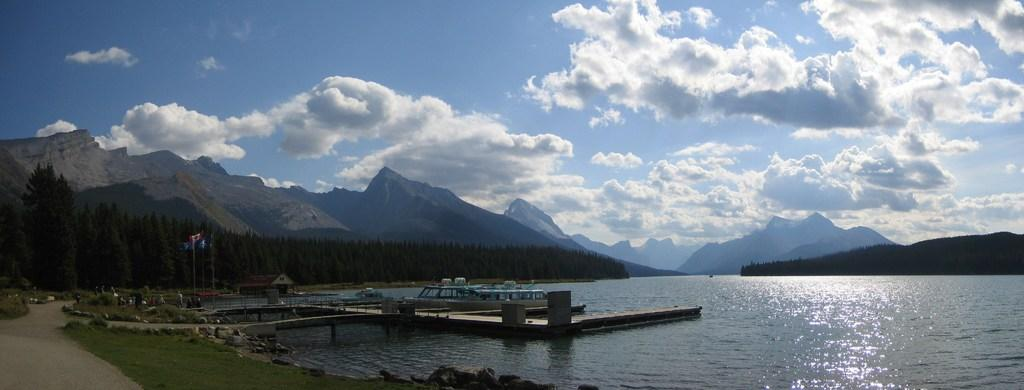What can be seen in the water in the image? There are many boats in the water. What is located to the left of the image? There is grass to the left of the image. What objects are present in the image that are not related to the boats or water? There are poles and flags in the image. What can be seen in the background of the image? There are trees, mountains, clouds, and the sky visible in the background of the image. What type of impulse can be seen affecting the boats in the image? There is no indication of any impulse affecting the boats in the image; they are stationary in the water. What kind of advice can be given to the trees in the background of the image? There is no need to give advice to the trees in the image, as they are not sentient beings capable of understanding or following advice. 